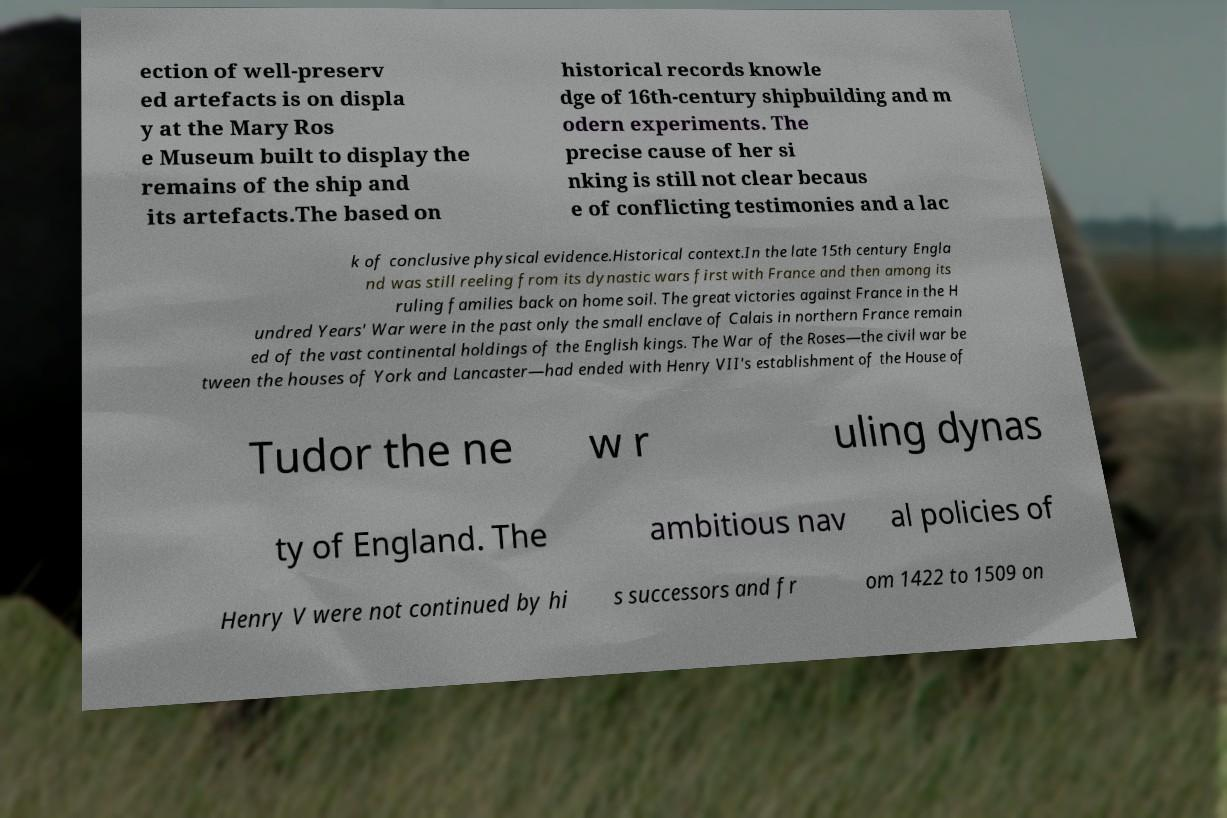Could you extract and type out the text from this image? ection of well-preserv ed artefacts is on displa y at the Mary Ros e Museum built to display the remains of the ship and its artefacts.The based on historical records knowle dge of 16th-century shipbuilding and m odern experiments. The precise cause of her si nking is still not clear becaus e of conflicting testimonies and a lac k of conclusive physical evidence.Historical context.In the late 15th century Engla nd was still reeling from its dynastic wars first with France and then among its ruling families back on home soil. The great victories against France in the H undred Years' War were in the past only the small enclave of Calais in northern France remain ed of the vast continental holdings of the English kings. The War of the Roses—the civil war be tween the houses of York and Lancaster—had ended with Henry VII's establishment of the House of Tudor the ne w r uling dynas ty of England. The ambitious nav al policies of Henry V were not continued by hi s successors and fr om 1422 to 1509 on 